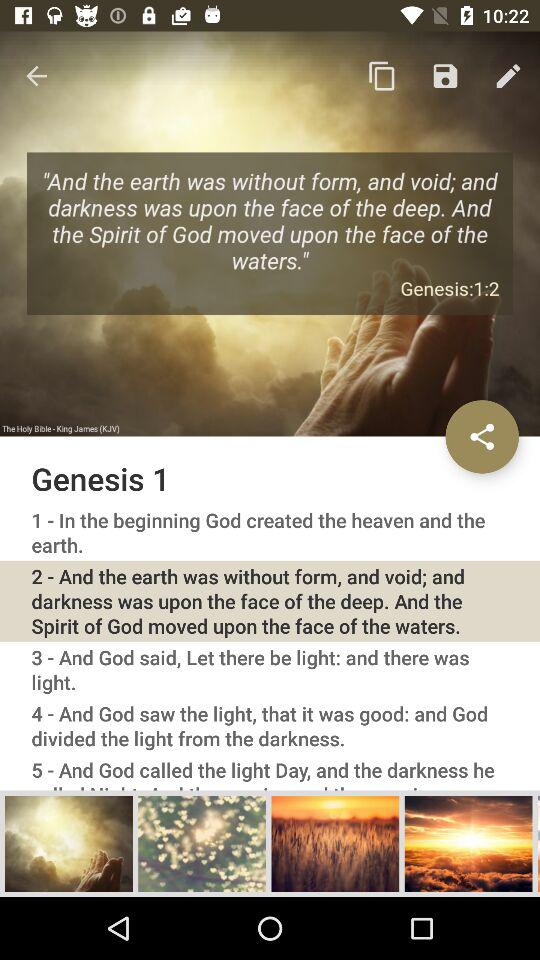Which "Genesis 1" is selected? The selected "Genesis 1" is "2 - And the earth was without form, and void; and darkness was upon the face of the deep. And the Spirit of God moved upon the face of the waters.". 